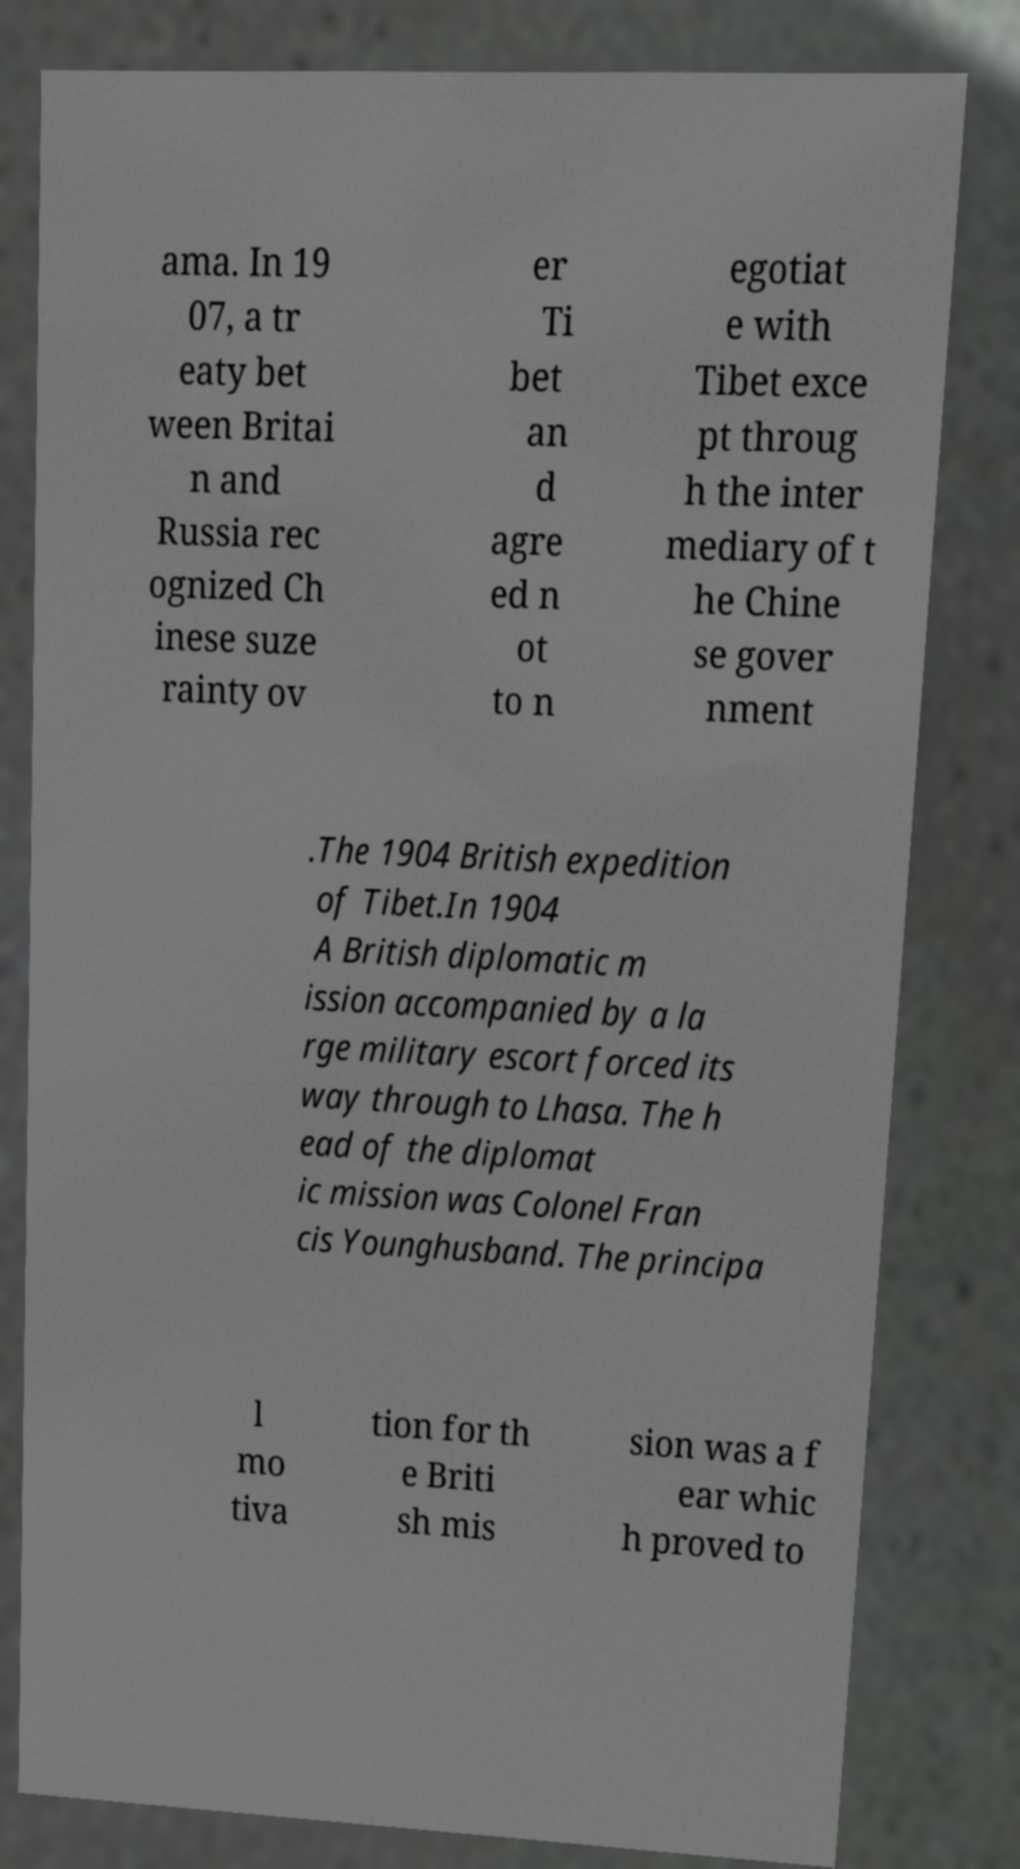Please identify and transcribe the text found in this image. ama. In 19 07, a tr eaty bet ween Britai n and Russia rec ognized Ch inese suze rainty ov er Ti bet an d agre ed n ot to n egotiat e with Tibet exce pt throug h the inter mediary of t he Chine se gover nment .The 1904 British expedition of Tibet.In 1904 A British diplomatic m ission accompanied by a la rge military escort forced its way through to Lhasa. The h ead of the diplomat ic mission was Colonel Fran cis Younghusband. The principa l mo tiva tion for th e Briti sh mis sion was a f ear whic h proved to 